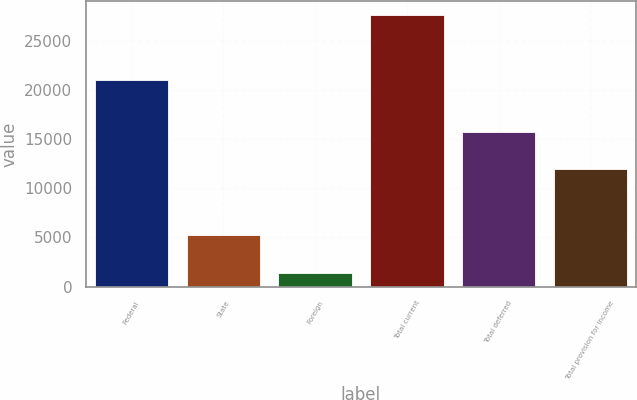<chart> <loc_0><loc_0><loc_500><loc_500><bar_chart><fcel>Federal<fcel>State<fcel>Foreign<fcel>Total current<fcel>Total deferred<fcel>Total provision for income<nl><fcel>21057<fcel>5251<fcel>1350<fcel>27658<fcel>15695<fcel>11963<nl></chart> 